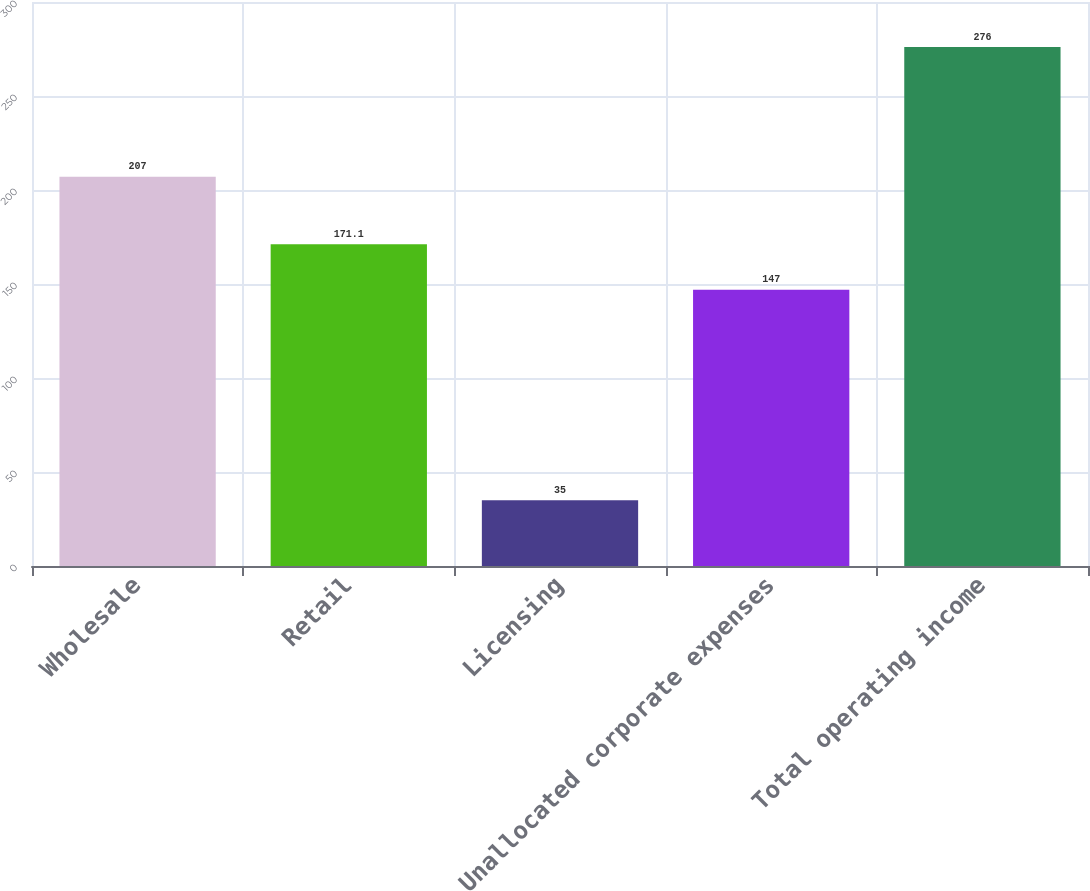Convert chart to OTSL. <chart><loc_0><loc_0><loc_500><loc_500><bar_chart><fcel>Wholesale<fcel>Retail<fcel>Licensing<fcel>Unallocated corporate expenses<fcel>Total operating income<nl><fcel>207<fcel>171.1<fcel>35<fcel>147<fcel>276<nl></chart> 